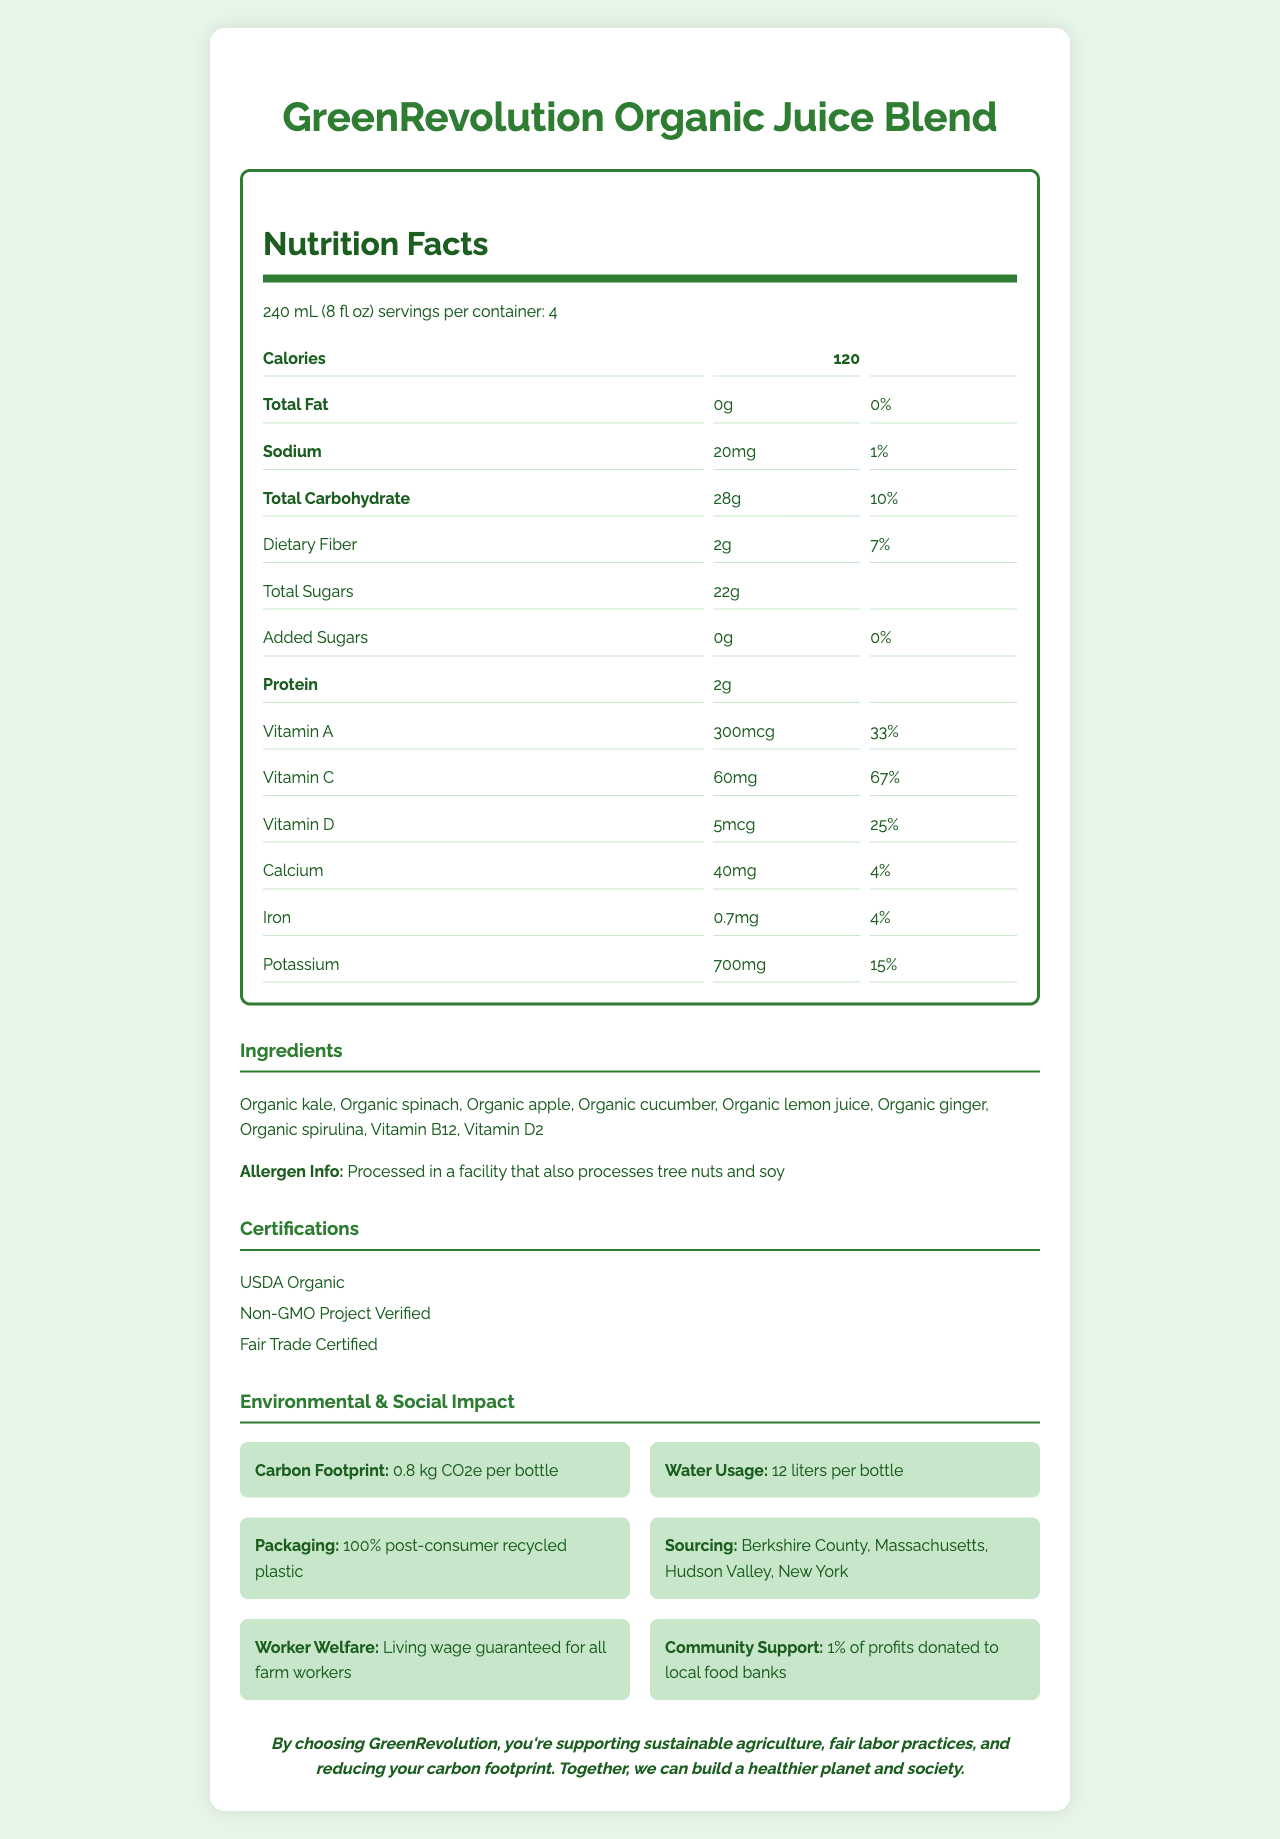what is the serving size? The serving size is explicitly stated near the beginning of the document as "240 mL (8 fl oz)".
Answer: 240 mL (8 fl oz) how many servings are there per container? The document states that there are 4 servings per container.
Answer: 4 what are the total calories per serving? The total calories per serving are indicated in the document as 120.
Answer: 120 what is the amount of protein in one serving? The document specifies that each serving contains 2 grams of protein.
Answer: 2g what certifications does the product have? The document lists these certifications under the section titled "Certifications".
Answer: USDA Organic, Non-GMO Project Verified, Fair Trade Certified How much potassium is in one serving of the juice? A. 500mg B. 650mg C. 700mg D. 750mg In the nutrition label section, it is stated that there are 700mg of potassium per serving.
Answer: C Which farm locations are involved in sourcing the ingredients? I. Berkshire County, Massachusetts II. Hudson Valley, New York III. San Joaquin Valley, California IV. Willamette Valley, Oregon The sourcing information section lists the farm locations as Berkshire County, Massachusetts, and Hudson Valley, New York.
Answer: I, II is there any added sugar in the juice? The document clearly states that the total added sugars amount is 0g.
Answer: No does the product support any social initiatives? The document mentions that 1% of profits are donated to local food banks, contributing to community support.
Answer: Yes Summarize the main idea of the document. The main idea of the document is to convey the health benefits, sustainability, and social responsibility aspects of the GreenRevolution Organic Juice Blend, emphasizing its organic and locally-sourced ingredients, low environmental footprint, and fair labor practices.
Answer: The document provides detailed information about the GreenRevolution Organic Juice Blend, including nutritional facts, ingredients, allergen information, certifications, environmental impact, sourcing information, social impact, and a political statement promoting sustainable and fair labor practices. What is the price per bottle of the juice? The document does not provide any information on the price of the product.
Answer: Not enough information 